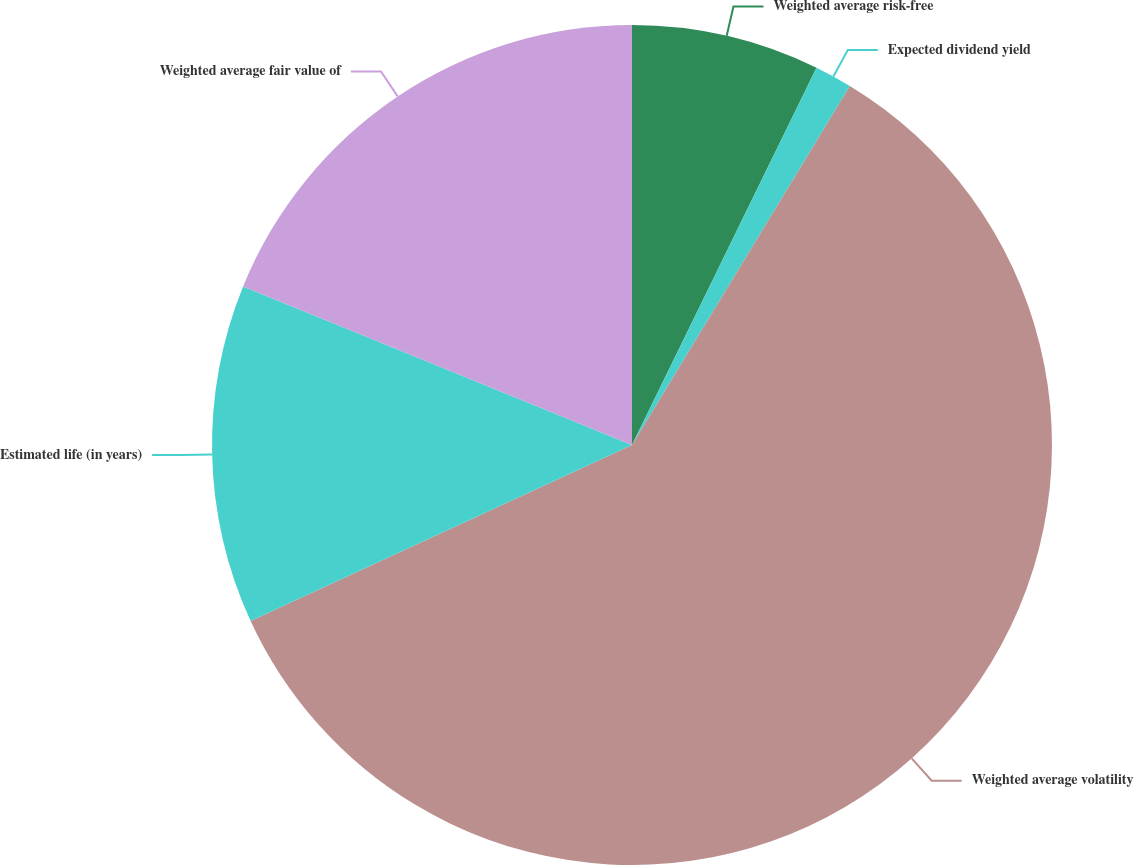Convert chart. <chart><loc_0><loc_0><loc_500><loc_500><pie_chart><fcel>Weighted average risk-free<fcel>Expected dividend yield<fcel>Weighted average volatility<fcel>Estimated life (in years)<fcel>Weighted average fair value of<nl><fcel>7.24%<fcel>1.44%<fcel>59.45%<fcel>13.04%<fcel>18.84%<nl></chart> 